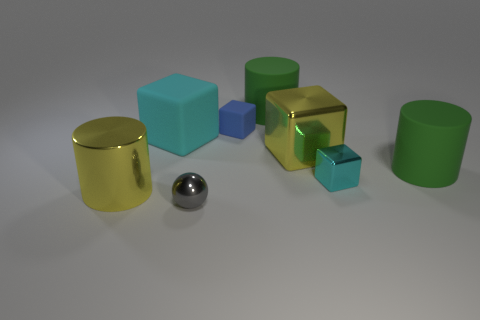Is the shape of the yellow thing on the left side of the small metal sphere the same as the green thing that is in front of the large rubber block?
Ensure brevity in your answer.  Yes. There is a object that is both in front of the small cyan cube and on the left side of the tiny gray metal object; what is its size?
Make the answer very short. Large. There is another small metal object that is the same shape as the small blue thing; what is its color?
Your response must be concise. Cyan. There is a small object in front of the metal object that is left of the gray metallic ball; what color is it?
Make the answer very short. Gray. What is the shape of the tiny gray thing?
Your response must be concise. Sphere. What is the shape of the metal thing that is left of the tiny blue object and to the right of the large cyan block?
Offer a terse response. Sphere. There is a block that is made of the same material as the blue object; what color is it?
Keep it short and to the point. Cyan. The yellow thing that is in front of the big matte thing on the right side of the yellow thing that is right of the yellow cylinder is what shape?
Make the answer very short. Cylinder. What size is the gray object?
Provide a succinct answer. Small. There is a yellow thing that is made of the same material as the large yellow block; what is its shape?
Give a very brief answer. Cylinder. 